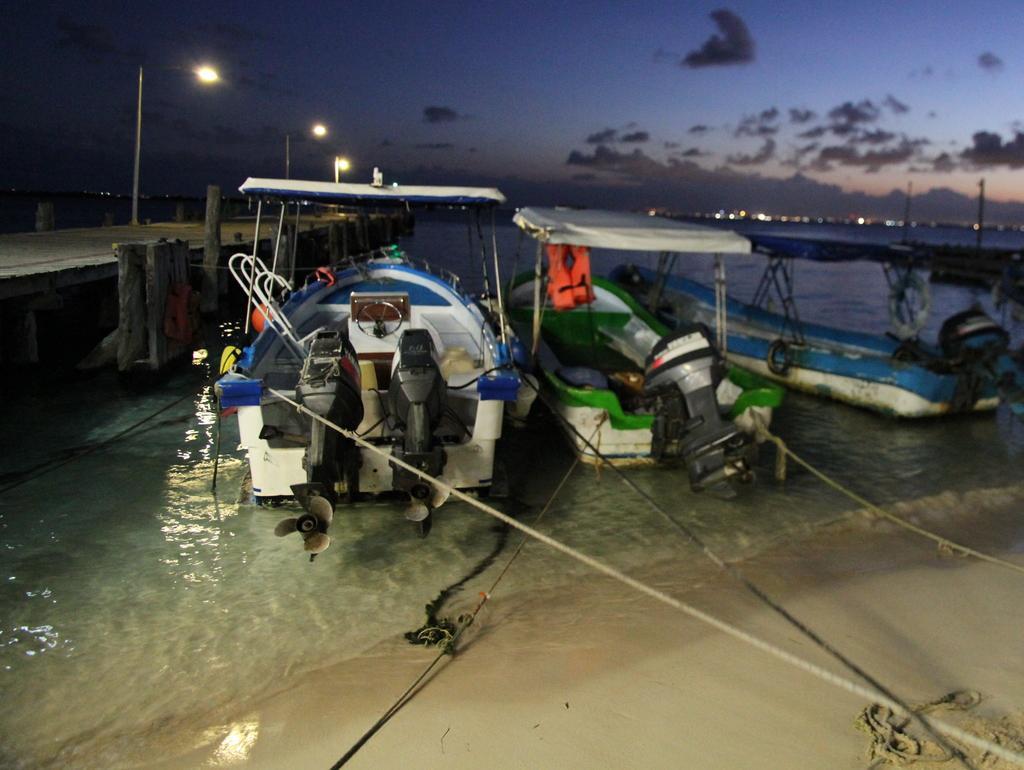In one or two sentences, can you explain what this image depicts? Here in this picture we can see number of steamer boats present in the river over there, as we can see water all over there and beside that we can see a wooden bridge present and we can see light posts present all over there and we can see clouds in sky. 